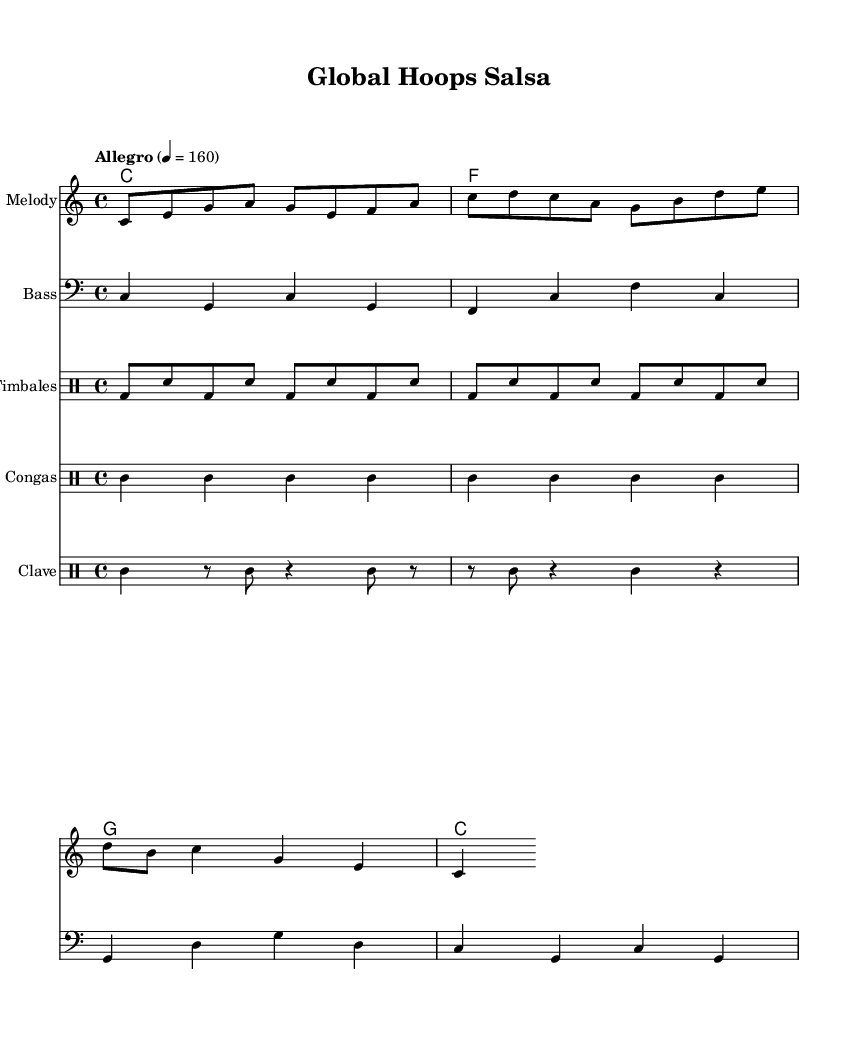What is the key signature of this music? The key signature is indicated at the beginning of the piece. The notation shows no sharps or flats, which corresponds to C major.
Answer: C major What is the time signature of this music? The time signature is written at the beginning of the piece, presented as "4/4", meaning there are four beats in each measure and a quarter note gets one beat.
Answer: 4/4 What is the tempo marking for this piece? The tempo marking is found at the start of the score as "Allegro" with a metronome marking of 160 beats per minute, indicating a fast pace.
Answer: Allegro, 160 What instruments are featured in this arrangement? The instruments are listed in the score's staff headers, including Melody, Bass, Timbales, Congas, and Clave, which together create the salsa sound.
Answer: Melody, Bass, Timbales, Congas, Clave How many measures are in the melody section? To find the number of measures, count each grouping of notes separated by vertical lines; there are four measures indicated in the melody line.
Answer: 4 What rhythmic pattern is established by the clave? The clave rhythm is unique to Latin music; in this score, it consists of a two-bar pattern featuring alternating accented and unaccented beats, highlighting the syncopation common in salsa music.
Answer: 2-bar pattern How does the bass interact with the melody in terms of rhythmic structure? The bass line follows a 4/4 time structure, supporting the melody with a consistent rhythm that complements the melodic phrases, providing a solid foundation for the salsa feel.
Answer: Complementary rhythm 